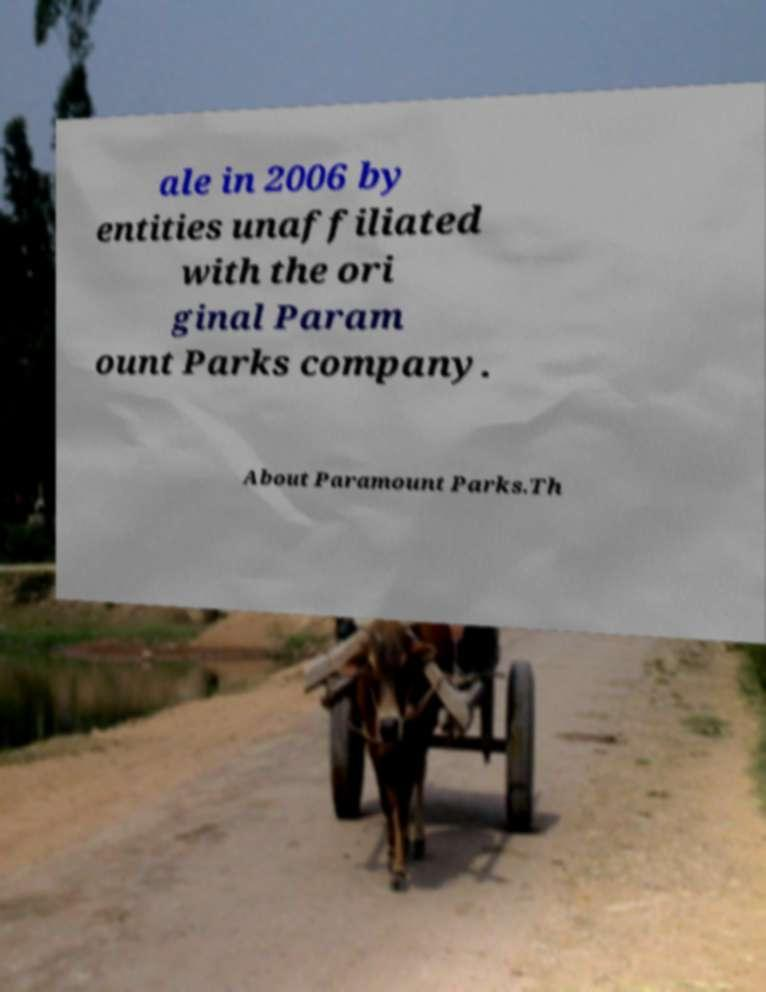What messages or text are displayed in this image? I need them in a readable, typed format. ale in 2006 by entities unaffiliated with the ori ginal Param ount Parks company. About Paramount Parks.Th 